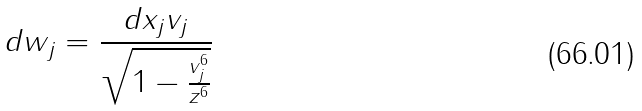<formula> <loc_0><loc_0><loc_500><loc_500>d w _ { j } = \frac { d x _ { j } v _ { j } } { \sqrt { 1 - \frac { v _ { j } ^ { 6 } } { z ^ { 6 } } } }</formula> 